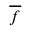Convert formula to latex. <formula><loc_0><loc_0><loc_500><loc_500>\overline { f }</formula> 